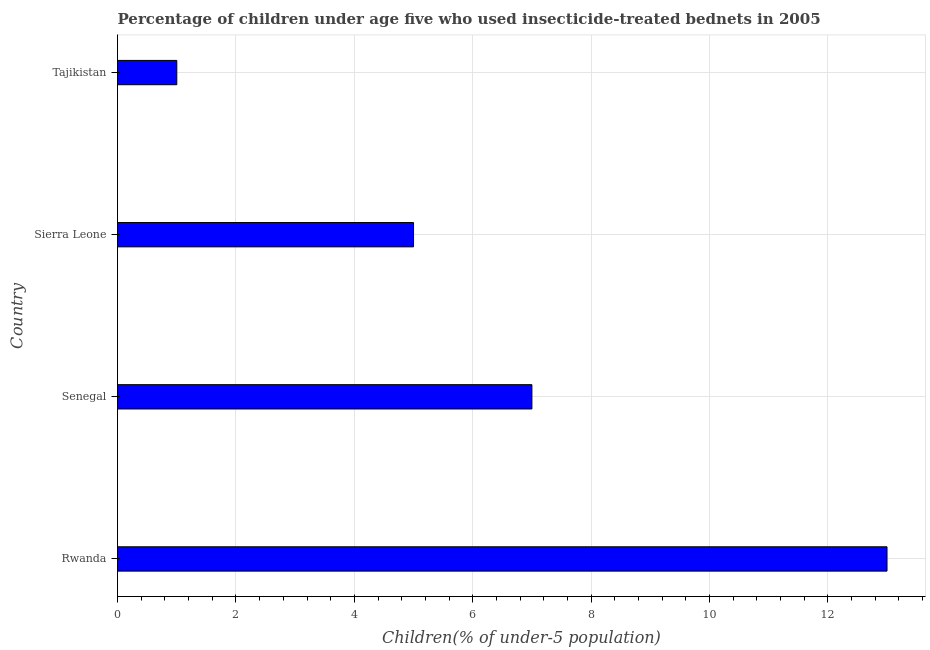Does the graph contain any zero values?
Provide a short and direct response. No. Does the graph contain grids?
Your answer should be very brief. Yes. What is the title of the graph?
Provide a short and direct response. Percentage of children under age five who used insecticide-treated bednets in 2005. What is the label or title of the X-axis?
Your answer should be very brief. Children(% of under-5 population). What is the label or title of the Y-axis?
Make the answer very short. Country. What is the percentage of children who use of insecticide-treated bed nets in Rwanda?
Offer a terse response. 13. Across all countries, what is the minimum percentage of children who use of insecticide-treated bed nets?
Your response must be concise. 1. In which country was the percentage of children who use of insecticide-treated bed nets maximum?
Give a very brief answer. Rwanda. In which country was the percentage of children who use of insecticide-treated bed nets minimum?
Provide a succinct answer. Tajikistan. What is the sum of the percentage of children who use of insecticide-treated bed nets?
Your response must be concise. 26. What is the difference between the percentage of children who use of insecticide-treated bed nets in Rwanda and Senegal?
Ensure brevity in your answer.  6. What is the average percentage of children who use of insecticide-treated bed nets per country?
Your answer should be compact. 6. What is the median percentage of children who use of insecticide-treated bed nets?
Ensure brevity in your answer.  6. In how many countries, is the percentage of children who use of insecticide-treated bed nets greater than 8.8 %?
Your response must be concise. 1. What is the ratio of the percentage of children who use of insecticide-treated bed nets in Rwanda to that in Tajikistan?
Offer a terse response. 13. Is the difference between the percentage of children who use of insecticide-treated bed nets in Sierra Leone and Tajikistan greater than the difference between any two countries?
Offer a terse response. No. What is the difference between the highest and the second highest percentage of children who use of insecticide-treated bed nets?
Your answer should be compact. 6. Is the sum of the percentage of children who use of insecticide-treated bed nets in Senegal and Tajikistan greater than the maximum percentage of children who use of insecticide-treated bed nets across all countries?
Ensure brevity in your answer.  No. What is the difference between the highest and the lowest percentage of children who use of insecticide-treated bed nets?
Make the answer very short. 12. In how many countries, is the percentage of children who use of insecticide-treated bed nets greater than the average percentage of children who use of insecticide-treated bed nets taken over all countries?
Make the answer very short. 2. How many bars are there?
Give a very brief answer. 4. Are the values on the major ticks of X-axis written in scientific E-notation?
Give a very brief answer. No. What is the Children(% of under-5 population) in Sierra Leone?
Offer a very short reply. 5. What is the difference between the Children(% of under-5 population) in Rwanda and Sierra Leone?
Your response must be concise. 8. What is the ratio of the Children(% of under-5 population) in Rwanda to that in Senegal?
Make the answer very short. 1.86. What is the ratio of the Children(% of under-5 population) in Rwanda to that in Sierra Leone?
Ensure brevity in your answer.  2.6. What is the ratio of the Children(% of under-5 population) in Rwanda to that in Tajikistan?
Offer a terse response. 13. 